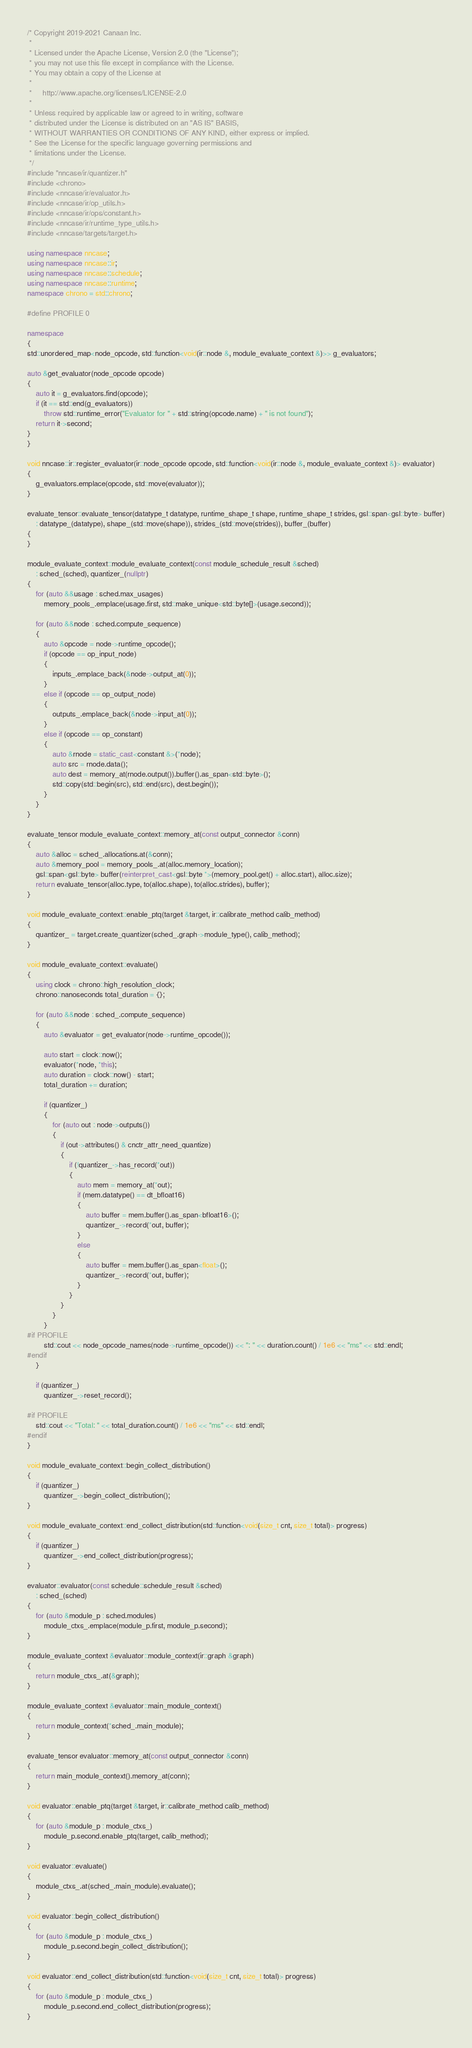<code> <loc_0><loc_0><loc_500><loc_500><_C++_>/* Copyright 2019-2021 Canaan Inc.
 *
 * Licensed under the Apache License, Version 2.0 (the "License");
 * you may not use this file except in compliance with the License.
 * You may obtain a copy of the License at
 *
 *     http://www.apache.org/licenses/LICENSE-2.0
 *
 * Unless required by applicable law or agreed to in writing, software
 * distributed under the License is distributed on an "AS IS" BASIS,
 * WITHOUT WARRANTIES OR CONDITIONS OF ANY KIND, either express or implied.
 * See the License for the specific language governing permissions and
 * limitations under the License.
 */
#include "nncase/ir/quantizer.h"
#include <chrono>
#include <nncase/ir/evaluator.h>
#include <nncase/ir/op_utils.h>
#include <nncase/ir/ops/constant.h>
#include <nncase/ir/runtime_type_utils.h>
#include <nncase/targets/target.h>

using namespace nncase;
using namespace nncase::ir;
using namespace nncase::schedule;
using namespace nncase::runtime;
namespace chrono = std::chrono;

#define PROFILE 0

namespace
{
std::unordered_map<node_opcode, std::function<void(ir::node &, module_evaluate_context &)>> g_evaluators;

auto &get_evaluator(node_opcode opcode)
{
    auto it = g_evaluators.find(opcode);
    if (it == std::end(g_evaluators))
        throw std::runtime_error("Evaluator for " + std::string(opcode.name) + " is not found");
    return it->second;
}
}

void nncase::ir::register_evaluator(ir::node_opcode opcode, std::function<void(ir::node &, module_evaluate_context &)> evaluator)
{
    g_evaluators.emplace(opcode, std::move(evaluator));
}

evaluate_tensor::evaluate_tensor(datatype_t datatype, runtime_shape_t shape, runtime_shape_t strides, gsl::span<gsl::byte> buffer)
    : datatype_(datatype), shape_(std::move(shape)), strides_(std::move(strides)), buffer_(buffer)
{
}

module_evaluate_context::module_evaluate_context(const module_schedule_result &sched)
    : sched_(sched), quantizer_(nullptr)
{
    for (auto &&usage : sched.max_usages)
        memory_pools_.emplace(usage.first, std::make_unique<std::byte[]>(usage.second));

    for (auto &&node : sched.compute_sequence)
    {
        auto &opcode = node->runtime_opcode();
        if (opcode == op_input_node)
        {
            inputs_.emplace_back(&node->output_at(0));
        }
        else if (opcode == op_output_node)
        {
            outputs_.emplace_back(&node->input_at(0));
        }
        else if (opcode == op_constant)
        {
            auto &rnode = static_cast<constant &>(*node);
            auto src = rnode.data();
            auto dest = memory_at(rnode.output()).buffer().as_span<std::byte>();
            std::copy(std::begin(src), std::end(src), dest.begin());
        }
    }
}

evaluate_tensor module_evaluate_context::memory_at(const output_connector &conn)
{
    auto &alloc = sched_.allocations.at(&conn);
    auto &memory_pool = memory_pools_.at(alloc.memory_location);
    gsl::span<gsl::byte> buffer(reinterpret_cast<gsl::byte *>(memory_pool.get() + alloc.start), alloc.size);
    return evaluate_tensor(alloc.type, to(alloc.shape), to(alloc.strides), buffer);
}

void module_evaluate_context::enable_ptq(target &target, ir::calibrate_method calib_method)
{
    quantizer_ = target.create_quantizer(sched_.graph->module_type(), calib_method);
}

void module_evaluate_context::evaluate()
{
    using clock = chrono::high_resolution_clock;
    chrono::nanoseconds total_duration = {};

    for (auto &&node : sched_.compute_sequence)
    {
        auto &evaluator = get_evaluator(node->runtime_opcode());

        auto start = clock::now();
        evaluator(*node, *this);
        auto duration = clock::now() - start;
        total_duration += duration;

        if (quantizer_)
        {
            for (auto out : node->outputs())
            {
                if (out->attributes() & cnctr_attr_need_quantize)
                {
                    if (!quantizer_->has_record(*out))
                    {
                        auto mem = memory_at(*out);
                        if (mem.datatype() == dt_bfloat16)
                        {
                            auto buffer = mem.buffer().as_span<bfloat16>();
                            quantizer_->record(*out, buffer);
                        }
                        else
                        {
                            auto buffer = mem.buffer().as_span<float>();
                            quantizer_->record(*out, buffer);
                        }
                    }
                }
            }
        }
#if PROFILE
        std::cout << node_opcode_names(node->runtime_opcode()) << ": " << duration.count() / 1e6 << "ms" << std::endl;
#endif
    }

    if (quantizer_)
        quantizer_->reset_record();

#if PROFILE
    std::cout << "Total: " << total_duration.count() / 1e6 << "ms" << std::endl;
#endif
}

void module_evaluate_context::begin_collect_distribution()
{
    if (quantizer_)
        quantizer_->begin_collect_distribution();
}

void module_evaluate_context::end_collect_distribution(std::function<void(size_t cnt, size_t total)> progress)
{
    if (quantizer_)
        quantizer_->end_collect_distribution(progress);
}

evaluator::evaluator(const schedule::schedule_result &sched)
    : sched_(sched)
{
    for (auto &module_p : sched.modules)
        module_ctxs_.emplace(module_p.first, module_p.second);
}

module_evaluate_context &evaluator::module_context(ir::graph &graph)
{
    return module_ctxs_.at(&graph);
}

module_evaluate_context &evaluator::main_module_context()
{
    return module_context(*sched_.main_module);
}

evaluate_tensor evaluator::memory_at(const output_connector &conn)
{
    return main_module_context().memory_at(conn);
}

void evaluator::enable_ptq(target &target, ir::calibrate_method calib_method)
{
    for (auto &module_p : module_ctxs_)
        module_p.second.enable_ptq(target, calib_method);
}

void evaluator::evaluate()
{
    module_ctxs_.at(sched_.main_module).evaluate();
}

void evaluator::begin_collect_distribution()
{
    for (auto &module_p : module_ctxs_)
        module_p.second.begin_collect_distribution();
}

void evaluator::end_collect_distribution(std::function<void(size_t cnt, size_t total)> progress)
{
    for (auto &module_p : module_ctxs_)
        module_p.second.end_collect_distribution(progress);
}
</code> 